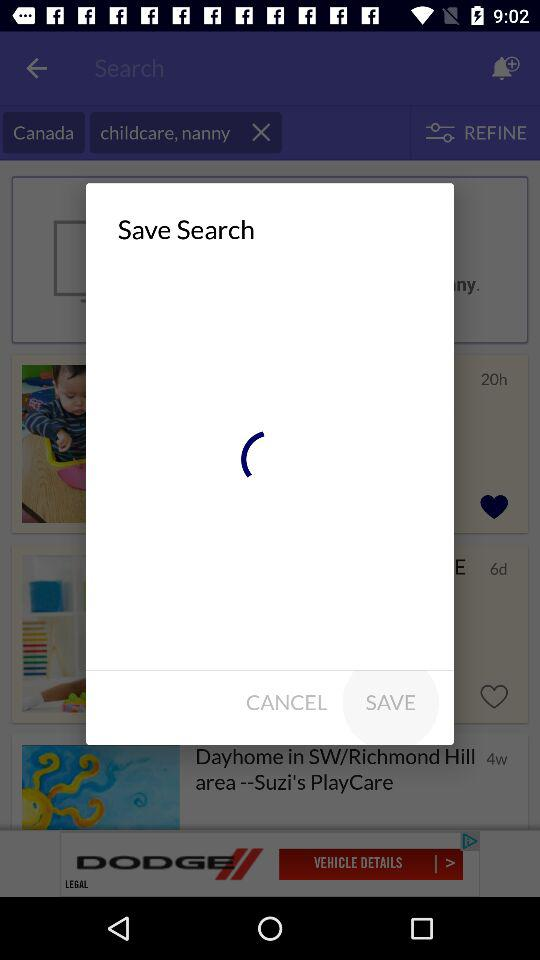What's the number for "Real Estate"? The number for "Real Estate" is 430,181. 